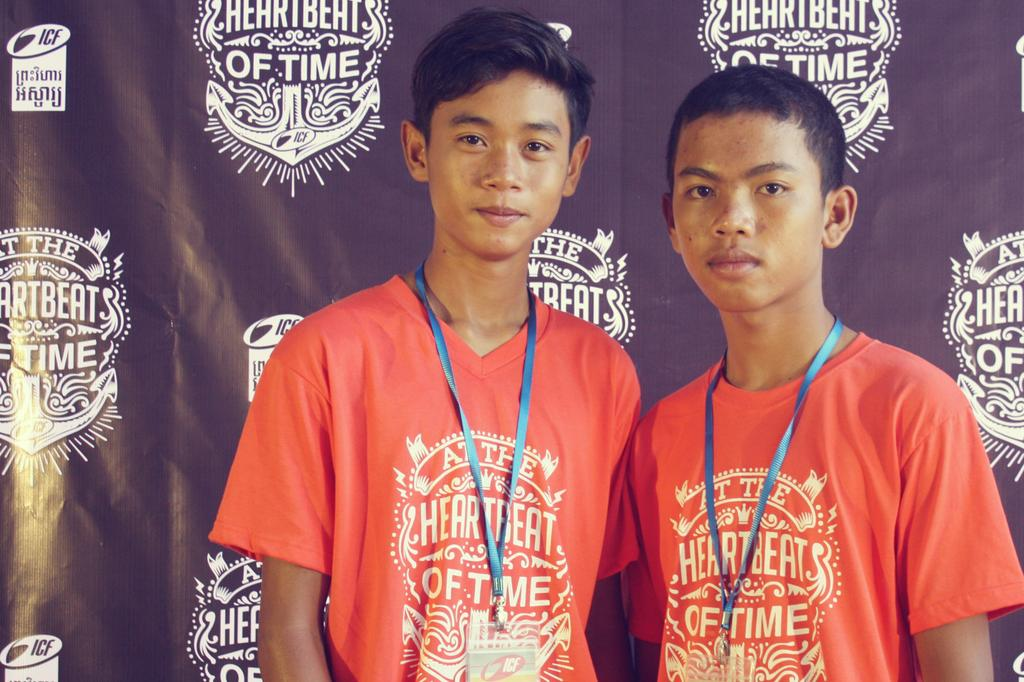What can be seen in the image? There are men standing in the image. What is visible in the background of the image? There is a curtain in the background of the image. What is the aftermath of the sand in the image? There is no sand present in the image, so it is not possible to discuss its aftermath. 